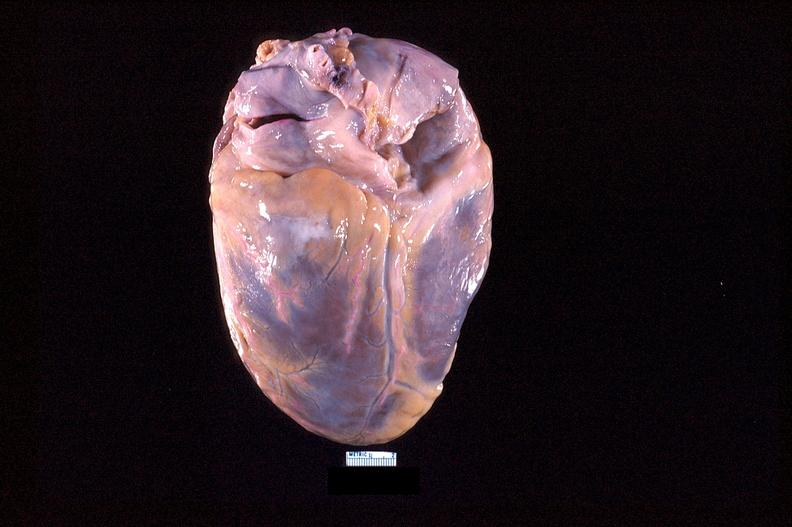s cardiovascular present?
Answer the question using a single word or phrase. Yes 